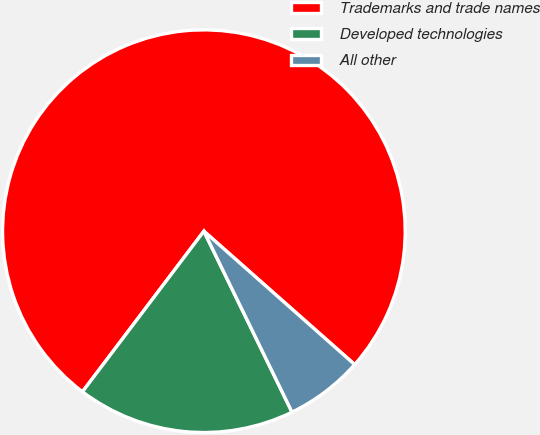Convert chart to OTSL. <chart><loc_0><loc_0><loc_500><loc_500><pie_chart><fcel>Trademarks and trade names<fcel>Developed technologies<fcel>All other<nl><fcel>76.22%<fcel>17.52%<fcel>6.26%<nl></chart> 